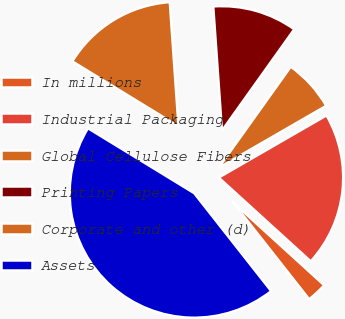Convert chart to OTSL. <chart><loc_0><loc_0><loc_500><loc_500><pie_chart><fcel>In millions<fcel>Industrial Packaging<fcel>Global Cellulose Fibers<fcel>Printing Papers<fcel>Corporate and other (d)<fcel>Assets<nl><fcel>2.64%<fcel>20.08%<fcel>6.81%<fcel>10.98%<fcel>15.15%<fcel>44.34%<nl></chart> 